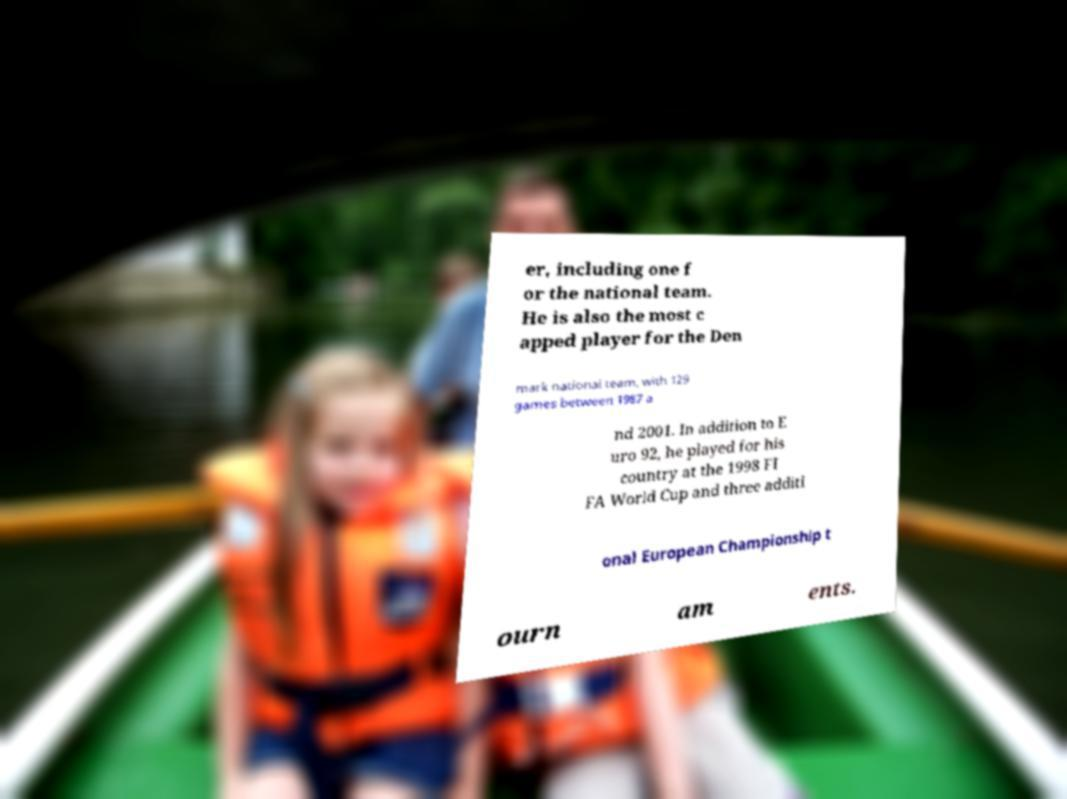Can you accurately transcribe the text from the provided image for me? er, including one f or the national team. He is also the most c apped player for the Den mark national team, with 129 games between 1987 a nd 2001. In addition to E uro 92, he played for his country at the 1998 FI FA World Cup and three additi onal European Championship t ourn am ents. 